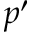<formula> <loc_0><loc_0><loc_500><loc_500>p ^ { \prime }</formula> 